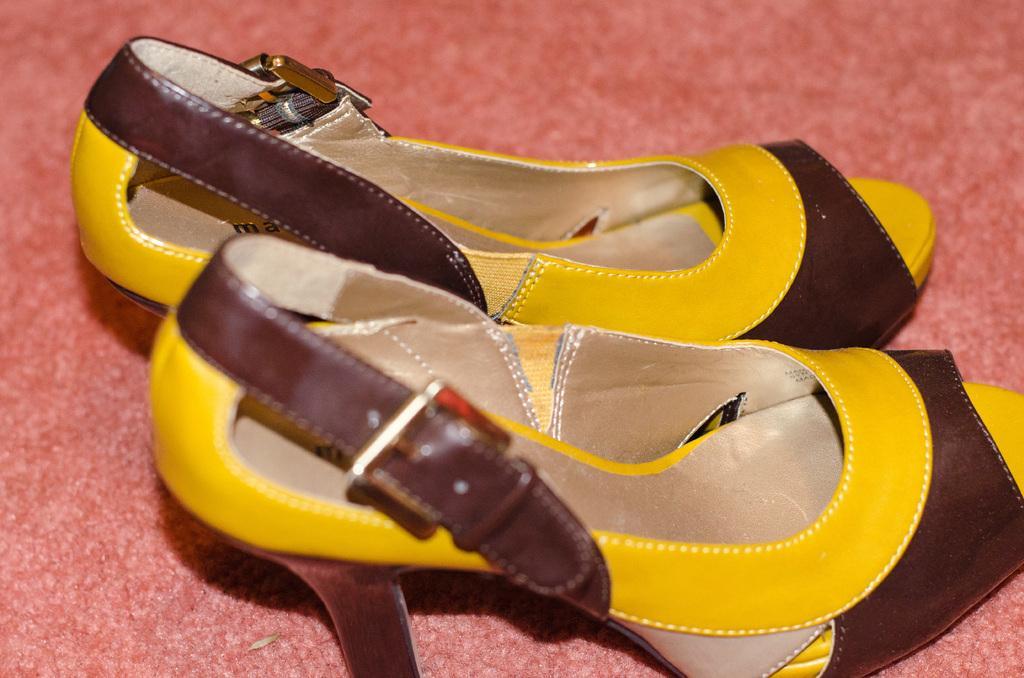Please provide a concise description of this image. In the center of the image we can see a footwear placed on the mat. 